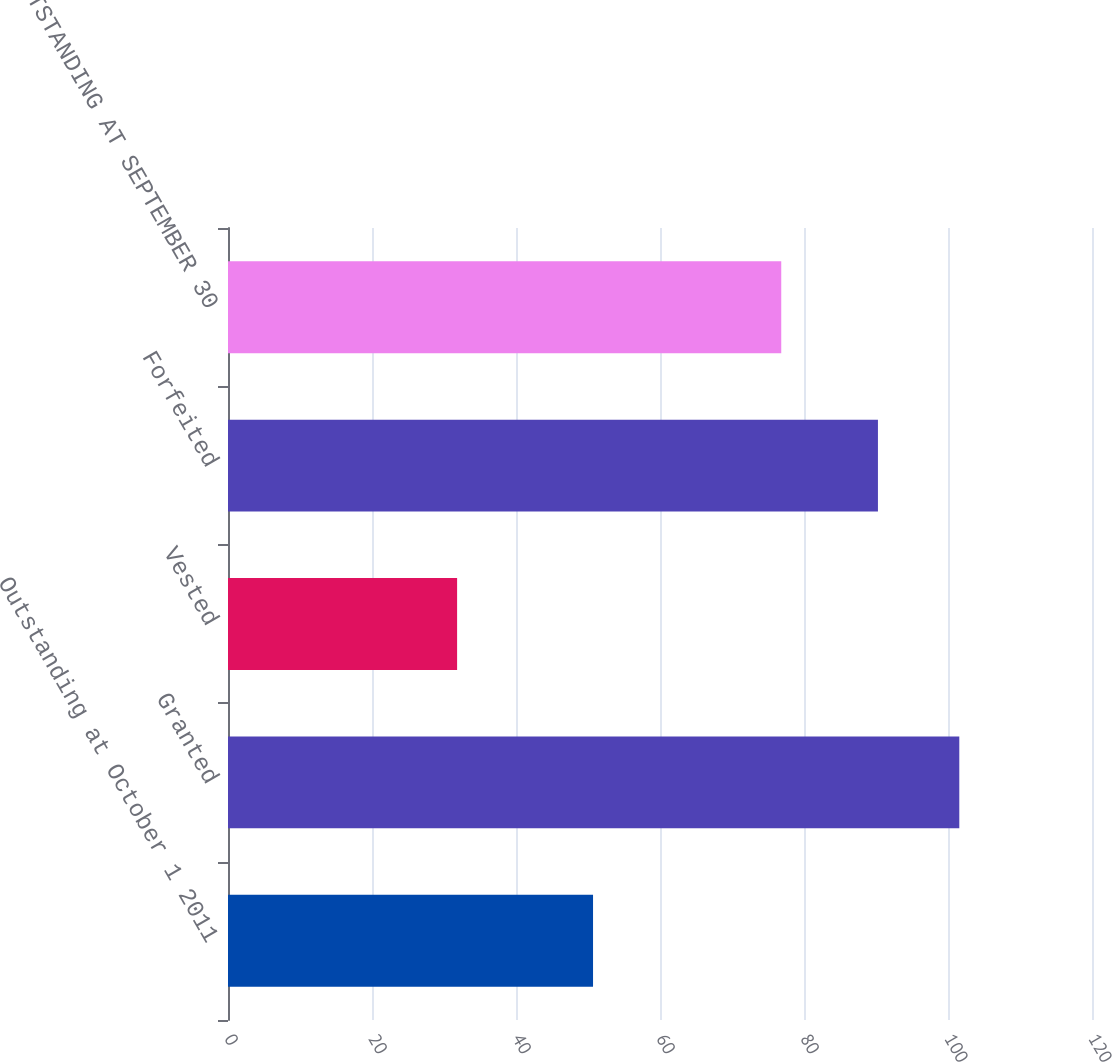<chart> <loc_0><loc_0><loc_500><loc_500><bar_chart><fcel>Outstanding at October 1 2011<fcel>Granted<fcel>Vested<fcel>Forfeited<fcel>OUTSTANDING AT SEPTEMBER 30<nl><fcel>50.7<fcel>101.57<fcel>31.82<fcel>90.27<fcel>76.84<nl></chart> 